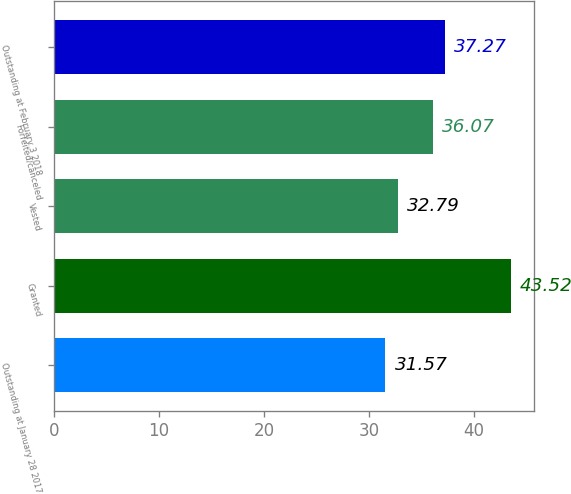<chart> <loc_0><loc_0><loc_500><loc_500><bar_chart><fcel>Outstanding at January 28 2017<fcel>Granted<fcel>Vested<fcel>Forfeited/canceled<fcel>Outstanding at February 3 2018<nl><fcel>31.57<fcel>43.52<fcel>32.79<fcel>36.07<fcel>37.27<nl></chart> 